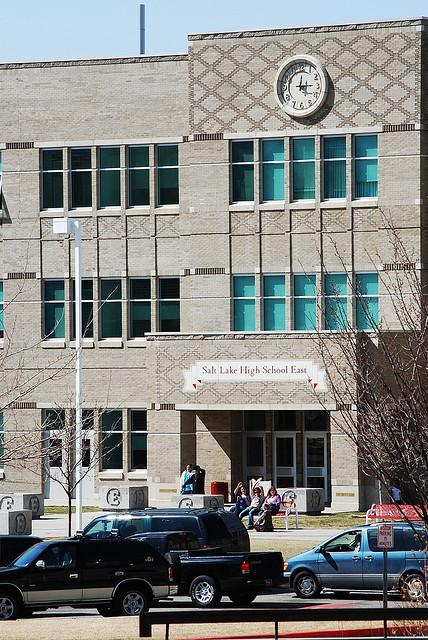What age people mostly utilize this space?

Choices:
A) toddlers
B) teens
C) senior citizens
D) adults teens 